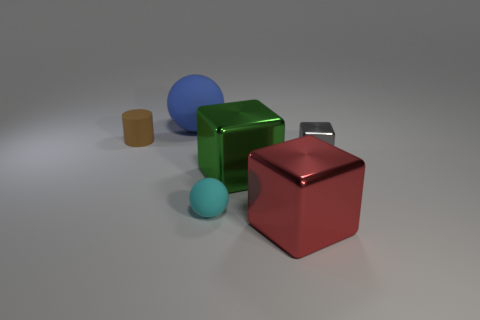Subtract all big green shiny blocks. How many blocks are left? 2 Add 3 large gray things. How many objects exist? 9 Subtract 2 blocks. How many blocks are left? 1 Subtract all cylinders. How many objects are left? 5 Subtract all red blocks. How many blue balls are left? 1 Subtract all green cubes. How many cubes are left? 2 Add 2 tiny gray metallic cubes. How many tiny gray metallic cubes are left? 3 Add 4 large red cubes. How many large red cubes exist? 5 Subtract 0 red spheres. How many objects are left? 6 Subtract all gray balls. Subtract all red cylinders. How many balls are left? 2 